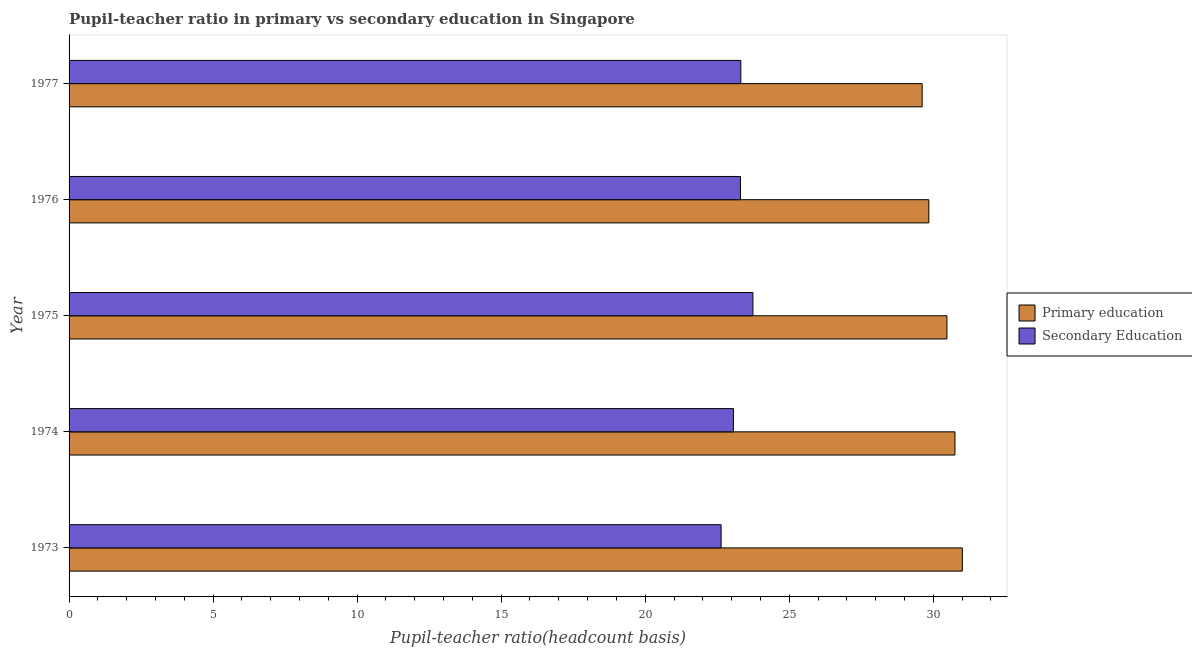How many different coloured bars are there?
Keep it short and to the point. 2. Are the number of bars per tick equal to the number of legend labels?
Keep it short and to the point. Yes. Are the number of bars on each tick of the Y-axis equal?
Give a very brief answer. Yes. How many bars are there on the 4th tick from the bottom?
Give a very brief answer. 2. What is the label of the 5th group of bars from the top?
Ensure brevity in your answer.  1973. What is the pupil teacher ratio on secondary education in 1976?
Provide a short and direct response. 23.31. Across all years, what is the maximum pupil-teacher ratio in primary education?
Offer a very short reply. 31.01. Across all years, what is the minimum pupil-teacher ratio in primary education?
Your answer should be compact. 29.61. What is the total pupil-teacher ratio in primary education in the graph?
Give a very brief answer. 151.69. What is the difference between the pupil teacher ratio on secondary education in 1975 and that in 1977?
Your answer should be compact. 0.42. What is the difference between the pupil-teacher ratio in primary education in 1976 and the pupil teacher ratio on secondary education in 1977?
Provide a succinct answer. 6.53. What is the average pupil-teacher ratio in primary education per year?
Make the answer very short. 30.34. In the year 1975, what is the difference between the pupil teacher ratio on secondary education and pupil-teacher ratio in primary education?
Your answer should be very brief. -6.73. What is the difference between the highest and the second highest pupil-teacher ratio in primary education?
Give a very brief answer. 0.26. What is the difference between the highest and the lowest pupil-teacher ratio in primary education?
Your response must be concise. 1.4. What does the 1st bar from the top in 1973 represents?
Ensure brevity in your answer.  Secondary Education. What does the 2nd bar from the bottom in 1973 represents?
Ensure brevity in your answer.  Secondary Education. How many bars are there?
Provide a short and direct response. 10. Are all the bars in the graph horizontal?
Your answer should be compact. Yes. What is the difference between two consecutive major ticks on the X-axis?
Your response must be concise. 5. Are the values on the major ticks of X-axis written in scientific E-notation?
Keep it short and to the point. No. Where does the legend appear in the graph?
Provide a succinct answer. Center right. What is the title of the graph?
Your answer should be compact. Pupil-teacher ratio in primary vs secondary education in Singapore. What is the label or title of the X-axis?
Ensure brevity in your answer.  Pupil-teacher ratio(headcount basis). What is the Pupil-teacher ratio(headcount basis) in Primary education in 1973?
Provide a succinct answer. 31.01. What is the Pupil-teacher ratio(headcount basis) of Secondary Education in 1973?
Offer a very short reply. 22.63. What is the Pupil-teacher ratio(headcount basis) in Primary education in 1974?
Provide a short and direct response. 30.75. What is the Pupil-teacher ratio(headcount basis) in Secondary Education in 1974?
Keep it short and to the point. 23.06. What is the Pupil-teacher ratio(headcount basis) of Primary education in 1975?
Offer a very short reply. 30.47. What is the Pupil-teacher ratio(headcount basis) in Secondary Education in 1975?
Give a very brief answer. 23.74. What is the Pupil-teacher ratio(headcount basis) in Primary education in 1976?
Offer a very short reply. 29.84. What is the Pupil-teacher ratio(headcount basis) of Secondary Education in 1976?
Keep it short and to the point. 23.31. What is the Pupil-teacher ratio(headcount basis) in Primary education in 1977?
Keep it short and to the point. 29.61. What is the Pupil-teacher ratio(headcount basis) of Secondary Education in 1977?
Make the answer very short. 23.32. Across all years, what is the maximum Pupil-teacher ratio(headcount basis) of Primary education?
Ensure brevity in your answer.  31.01. Across all years, what is the maximum Pupil-teacher ratio(headcount basis) in Secondary Education?
Your answer should be compact. 23.74. Across all years, what is the minimum Pupil-teacher ratio(headcount basis) in Primary education?
Make the answer very short. 29.61. Across all years, what is the minimum Pupil-teacher ratio(headcount basis) in Secondary Education?
Provide a short and direct response. 22.63. What is the total Pupil-teacher ratio(headcount basis) in Primary education in the graph?
Offer a very short reply. 151.69. What is the total Pupil-teacher ratio(headcount basis) in Secondary Education in the graph?
Give a very brief answer. 116.06. What is the difference between the Pupil-teacher ratio(headcount basis) in Primary education in 1973 and that in 1974?
Provide a short and direct response. 0.26. What is the difference between the Pupil-teacher ratio(headcount basis) in Secondary Education in 1973 and that in 1974?
Ensure brevity in your answer.  -0.43. What is the difference between the Pupil-teacher ratio(headcount basis) of Primary education in 1973 and that in 1975?
Ensure brevity in your answer.  0.54. What is the difference between the Pupil-teacher ratio(headcount basis) of Secondary Education in 1973 and that in 1975?
Provide a short and direct response. -1.1. What is the difference between the Pupil-teacher ratio(headcount basis) in Primary education in 1973 and that in 1976?
Keep it short and to the point. 1.16. What is the difference between the Pupil-teacher ratio(headcount basis) in Secondary Education in 1973 and that in 1976?
Ensure brevity in your answer.  -0.67. What is the difference between the Pupil-teacher ratio(headcount basis) in Primary education in 1973 and that in 1977?
Ensure brevity in your answer.  1.4. What is the difference between the Pupil-teacher ratio(headcount basis) of Secondary Education in 1973 and that in 1977?
Your answer should be very brief. -0.68. What is the difference between the Pupil-teacher ratio(headcount basis) in Primary education in 1974 and that in 1975?
Offer a very short reply. 0.28. What is the difference between the Pupil-teacher ratio(headcount basis) in Secondary Education in 1974 and that in 1975?
Your response must be concise. -0.68. What is the difference between the Pupil-teacher ratio(headcount basis) in Primary education in 1974 and that in 1976?
Ensure brevity in your answer.  0.91. What is the difference between the Pupil-teacher ratio(headcount basis) in Secondary Education in 1974 and that in 1976?
Your answer should be compact. -0.24. What is the difference between the Pupil-teacher ratio(headcount basis) in Primary education in 1974 and that in 1977?
Your answer should be very brief. 1.14. What is the difference between the Pupil-teacher ratio(headcount basis) in Secondary Education in 1974 and that in 1977?
Provide a short and direct response. -0.26. What is the difference between the Pupil-teacher ratio(headcount basis) of Primary education in 1975 and that in 1976?
Keep it short and to the point. 0.63. What is the difference between the Pupil-teacher ratio(headcount basis) of Secondary Education in 1975 and that in 1976?
Offer a very short reply. 0.43. What is the difference between the Pupil-teacher ratio(headcount basis) in Primary education in 1975 and that in 1977?
Offer a terse response. 0.86. What is the difference between the Pupil-teacher ratio(headcount basis) of Secondary Education in 1975 and that in 1977?
Your answer should be compact. 0.42. What is the difference between the Pupil-teacher ratio(headcount basis) in Primary education in 1976 and that in 1977?
Offer a very short reply. 0.23. What is the difference between the Pupil-teacher ratio(headcount basis) in Secondary Education in 1976 and that in 1977?
Make the answer very short. -0.01. What is the difference between the Pupil-teacher ratio(headcount basis) in Primary education in 1973 and the Pupil-teacher ratio(headcount basis) in Secondary Education in 1974?
Give a very brief answer. 7.95. What is the difference between the Pupil-teacher ratio(headcount basis) of Primary education in 1973 and the Pupil-teacher ratio(headcount basis) of Secondary Education in 1975?
Keep it short and to the point. 7.27. What is the difference between the Pupil-teacher ratio(headcount basis) in Primary education in 1973 and the Pupil-teacher ratio(headcount basis) in Secondary Education in 1976?
Make the answer very short. 7.7. What is the difference between the Pupil-teacher ratio(headcount basis) in Primary education in 1973 and the Pupil-teacher ratio(headcount basis) in Secondary Education in 1977?
Make the answer very short. 7.69. What is the difference between the Pupil-teacher ratio(headcount basis) of Primary education in 1974 and the Pupil-teacher ratio(headcount basis) of Secondary Education in 1975?
Offer a terse response. 7.01. What is the difference between the Pupil-teacher ratio(headcount basis) in Primary education in 1974 and the Pupil-teacher ratio(headcount basis) in Secondary Education in 1976?
Ensure brevity in your answer.  7.45. What is the difference between the Pupil-teacher ratio(headcount basis) in Primary education in 1974 and the Pupil-teacher ratio(headcount basis) in Secondary Education in 1977?
Make the answer very short. 7.43. What is the difference between the Pupil-teacher ratio(headcount basis) of Primary education in 1975 and the Pupil-teacher ratio(headcount basis) of Secondary Education in 1976?
Provide a short and direct response. 7.17. What is the difference between the Pupil-teacher ratio(headcount basis) in Primary education in 1975 and the Pupil-teacher ratio(headcount basis) in Secondary Education in 1977?
Keep it short and to the point. 7.15. What is the difference between the Pupil-teacher ratio(headcount basis) in Primary education in 1976 and the Pupil-teacher ratio(headcount basis) in Secondary Education in 1977?
Your answer should be compact. 6.53. What is the average Pupil-teacher ratio(headcount basis) of Primary education per year?
Offer a very short reply. 30.34. What is the average Pupil-teacher ratio(headcount basis) of Secondary Education per year?
Your answer should be compact. 23.21. In the year 1973, what is the difference between the Pupil-teacher ratio(headcount basis) in Primary education and Pupil-teacher ratio(headcount basis) in Secondary Education?
Ensure brevity in your answer.  8.37. In the year 1974, what is the difference between the Pupil-teacher ratio(headcount basis) in Primary education and Pupil-teacher ratio(headcount basis) in Secondary Education?
Give a very brief answer. 7.69. In the year 1975, what is the difference between the Pupil-teacher ratio(headcount basis) of Primary education and Pupil-teacher ratio(headcount basis) of Secondary Education?
Offer a very short reply. 6.73. In the year 1976, what is the difference between the Pupil-teacher ratio(headcount basis) in Primary education and Pupil-teacher ratio(headcount basis) in Secondary Education?
Your response must be concise. 6.54. In the year 1977, what is the difference between the Pupil-teacher ratio(headcount basis) in Primary education and Pupil-teacher ratio(headcount basis) in Secondary Education?
Offer a very short reply. 6.29. What is the ratio of the Pupil-teacher ratio(headcount basis) of Primary education in 1973 to that in 1974?
Give a very brief answer. 1.01. What is the ratio of the Pupil-teacher ratio(headcount basis) in Secondary Education in 1973 to that in 1974?
Give a very brief answer. 0.98. What is the ratio of the Pupil-teacher ratio(headcount basis) in Primary education in 1973 to that in 1975?
Ensure brevity in your answer.  1.02. What is the ratio of the Pupil-teacher ratio(headcount basis) of Secondary Education in 1973 to that in 1975?
Keep it short and to the point. 0.95. What is the ratio of the Pupil-teacher ratio(headcount basis) of Primary education in 1973 to that in 1976?
Make the answer very short. 1.04. What is the ratio of the Pupil-teacher ratio(headcount basis) of Secondary Education in 1973 to that in 1976?
Offer a very short reply. 0.97. What is the ratio of the Pupil-teacher ratio(headcount basis) of Primary education in 1973 to that in 1977?
Offer a very short reply. 1.05. What is the ratio of the Pupil-teacher ratio(headcount basis) of Secondary Education in 1973 to that in 1977?
Ensure brevity in your answer.  0.97. What is the ratio of the Pupil-teacher ratio(headcount basis) in Primary education in 1974 to that in 1975?
Provide a succinct answer. 1.01. What is the ratio of the Pupil-teacher ratio(headcount basis) in Secondary Education in 1974 to that in 1975?
Keep it short and to the point. 0.97. What is the ratio of the Pupil-teacher ratio(headcount basis) of Primary education in 1974 to that in 1976?
Provide a succinct answer. 1.03. What is the ratio of the Pupil-teacher ratio(headcount basis) of Primary education in 1974 to that in 1977?
Make the answer very short. 1.04. What is the ratio of the Pupil-teacher ratio(headcount basis) in Secondary Education in 1974 to that in 1977?
Make the answer very short. 0.99. What is the ratio of the Pupil-teacher ratio(headcount basis) in Secondary Education in 1975 to that in 1976?
Ensure brevity in your answer.  1.02. What is the ratio of the Pupil-teacher ratio(headcount basis) of Primary education in 1975 to that in 1977?
Your answer should be very brief. 1.03. What is the ratio of the Pupil-teacher ratio(headcount basis) in Secondary Education in 1975 to that in 1977?
Your answer should be very brief. 1.02. What is the ratio of the Pupil-teacher ratio(headcount basis) in Primary education in 1976 to that in 1977?
Give a very brief answer. 1.01. What is the ratio of the Pupil-teacher ratio(headcount basis) in Secondary Education in 1976 to that in 1977?
Your response must be concise. 1. What is the difference between the highest and the second highest Pupil-teacher ratio(headcount basis) in Primary education?
Provide a short and direct response. 0.26. What is the difference between the highest and the second highest Pupil-teacher ratio(headcount basis) of Secondary Education?
Make the answer very short. 0.42. What is the difference between the highest and the lowest Pupil-teacher ratio(headcount basis) of Primary education?
Your response must be concise. 1.4. What is the difference between the highest and the lowest Pupil-teacher ratio(headcount basis) in Secondary Education?
Provide a short and direct response. 1.1. 